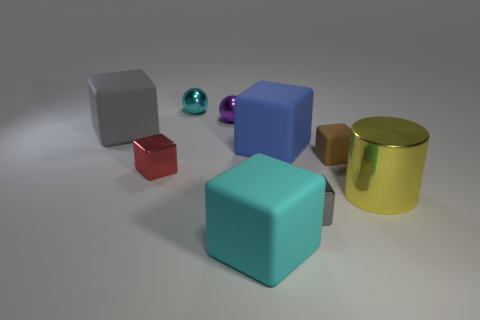Subtract all red metal blocks. How many blocks are left? 5 Subtract all red cubes. How many cubes are left? 5 Add 1 gray shiny balls. How many objects exist? 10 Subtract all green cubes. Subtract all brown cylinders. How many cubes are left? 6 Subtract all balls. How many objects are left? 7 Subtract all tiny spheres. Subtract all gray metallic cubes. How many objects are left? 6 Add 2 tiny rubber objects. How many tiny rubber objects are left? 3 Add 6 big blue matte things. How many big blue matte things exist? 7 Subtract 0 green cylinders. How many objects are left? 9 